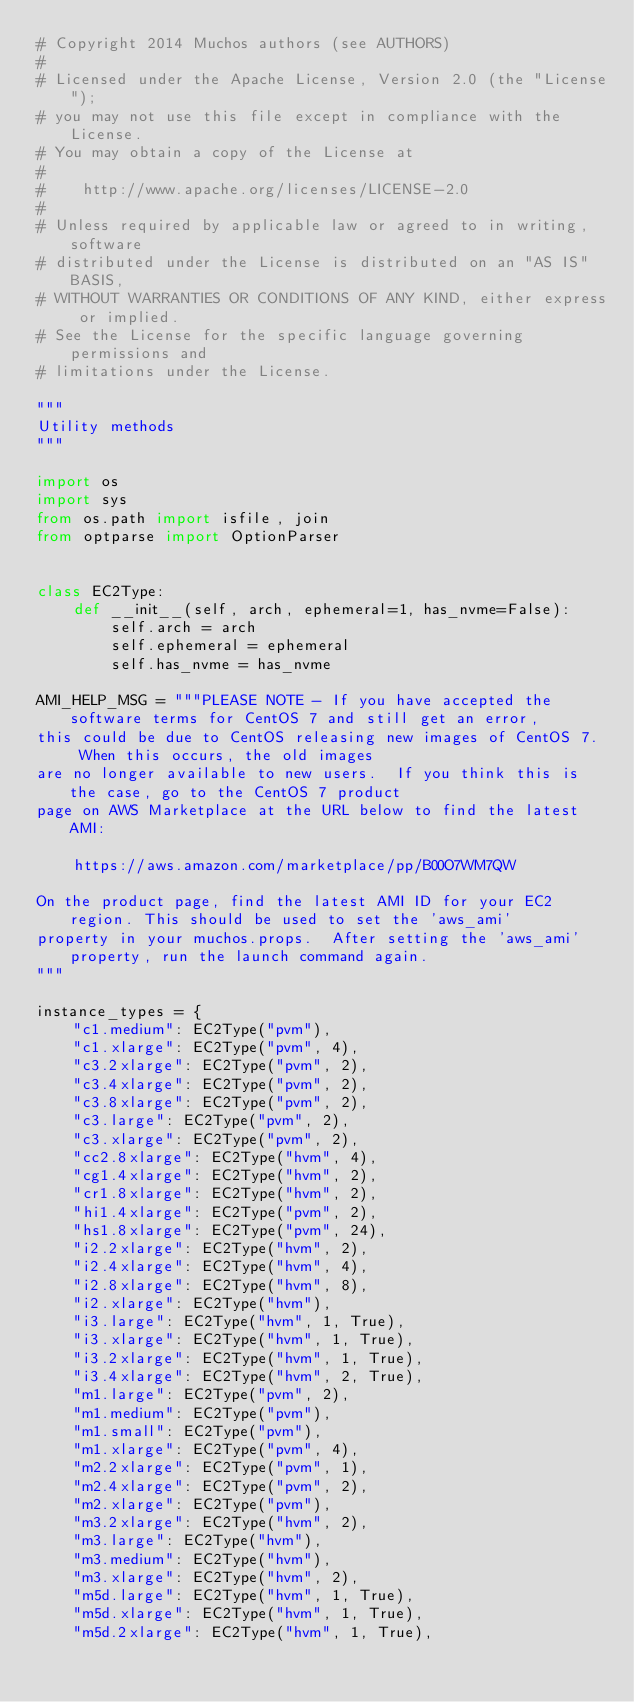Convert code to text. <code><loc_0><loc_0><loc_500><loc_500><_Python_># Copyright 2014 Muchos authors (see AUTHORS)
#
# Licensed under the Apache License, Version 2.0 (the "License");
# you may not use this file except in compliance with the License.
# You may obtain a copy of the License at
#
#    http://www.apache.org/licenses/LICENSE-2.0
#
# Unless required by applicable law or agreed to in writing, software
# distributed under the License is distributed on an "AS IS" BASIS,
# WITHOUT WARRANTIES OR CONDITIONS OF ANY KIND, either express or implied.
# See the License for the specific language governing permissions and
# limitations under the License.

"""
Utility methods
"""

import os
import sys
from os.path import isfile, join
from optparse import OptionParser


class EC2Type:
    def __init__(self, arch, ephemeral=1, has_nvme=False):
        self.arch = arch
        self.ephemeral = ephemeral
        self.has_nvme = has_nvme

AMI_HELP_MSG = """PLEASE NOTE - If you have accepted the software terms for CentOS 7 and still get an error,
this could be due to CentOS releasing new images of CentOS 7.  When this occurs, the old images
are no longer available to new users.  If you think this is the case, go to the CentOS 7 product
page on AWS Marketplace at the URL below to find the latest AMI:

    https://aws.amazon.com/marketplace/pp/B00O7WM7QW

On the product page, find the latest AMI ID for your EC2 region. This should be used to set the 'aws_ami'
property in your muchos.props.  After setting the 'aws_ami' property, run the launch command again.
"""

instance_types = {
    "c1.medium": EC2Type("pvm"),
    "c1.xlarge": EC2Type("pvm", 4),
    "c3.2xlarge": EC2Type("pvm", 2),
    "c3.4xlarge": EC2Type("pvm", 2),
    "c3.8xlarge": EC2Type("pvm", 2),
    "c3.large": EC2Type("pvm", 2),
    "c3.xlarge": EC2Type("pvm", 2),
    "cc2.8xlarge": EC2Type("hvm", 4),
    "cg1.4xlarge": EC2Type("hvm", 2),
    "cr1.8xlarge": EC2Type("hvm", 2),
    "hi1.4xlarge": EC2Type("pvm", 2),
    "hs1.8xlarge": EC2Type("pvm", 24),
    "i2.2xlarge": EC2Type("hvm", 2),
    "i2.4xlarge": EC2Type("hvm", 4),
    "i2.8xlarge": EC2Type("hvm", 8),
    "i2.xlarge": EC2Type("hvm"),
    "i3.large": EC2Type("hvm", 1, True),
    "i3.xlarge": EC2Type("hvm", 1, True),
    "i3.2xlarge": EC2Type("hvm", 1, True),
    "i3.4xlarge": EC2Type("hvm", 2, True),
    "m1.large": EC2Type("pvm", 2),
    "m1.medium": EC2Type("pvm"),
    "m1.small": EC2Type("pvm"),
    "m1.xlarge": EC2Type("pvm", 4),
    "m2.2xlarge": EC2Type("pvm", 1),
    "m2.4xlarge": EC2Type("pvm", 2),
    "m2.xlarge": EC2Type("pvm"),
    "m3.2xlarge": EC2Type("hvm", 2),
    "m3.large": EC2Type("hvm"),
    "m3.medium": EC2Type("hvm"),
    "m3.xlarge": EC2Type("hvm", 2),
    "m5d.large": EC2Type("hvm", 1, True),
    "m5d.xlarge": EC2Type("hvm", 1, True),
    "m5d.2xlarge": EC2Type("hvm", 1, True),</code> 